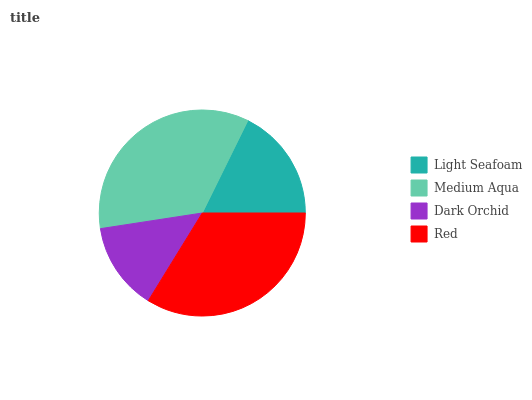Is Dark Orchid the minimum?
Answer yes or no. Yes. Is Medium Aqua the maximum?
Answer yes or no. Yes. Is Medium Aqua the minimum?
Answer yes or no. No. Is Dark Orchid the maximum?
Answer yes or no. No. Is Medium Aqua greater than Dark Orchid?
Answer yes or no. Yes. Is Dark Orchid less than Medium Aqua?
Answer yes or no. Yes. Is Dark Orchid greater than Medium Aqua?
Answer yes or no. No. Is Medium Aqua less than Dark Orchid?
Answer yes or no. No. Is Red the high median?
Answer yes or no. Yes. Is Light Seafoam the low median?
Answer yes or no. Yes. Is Light Seafoam the high median?
Answer yes or no. No. Is Medium Aqua the low median?
Answer yes or no. No. 